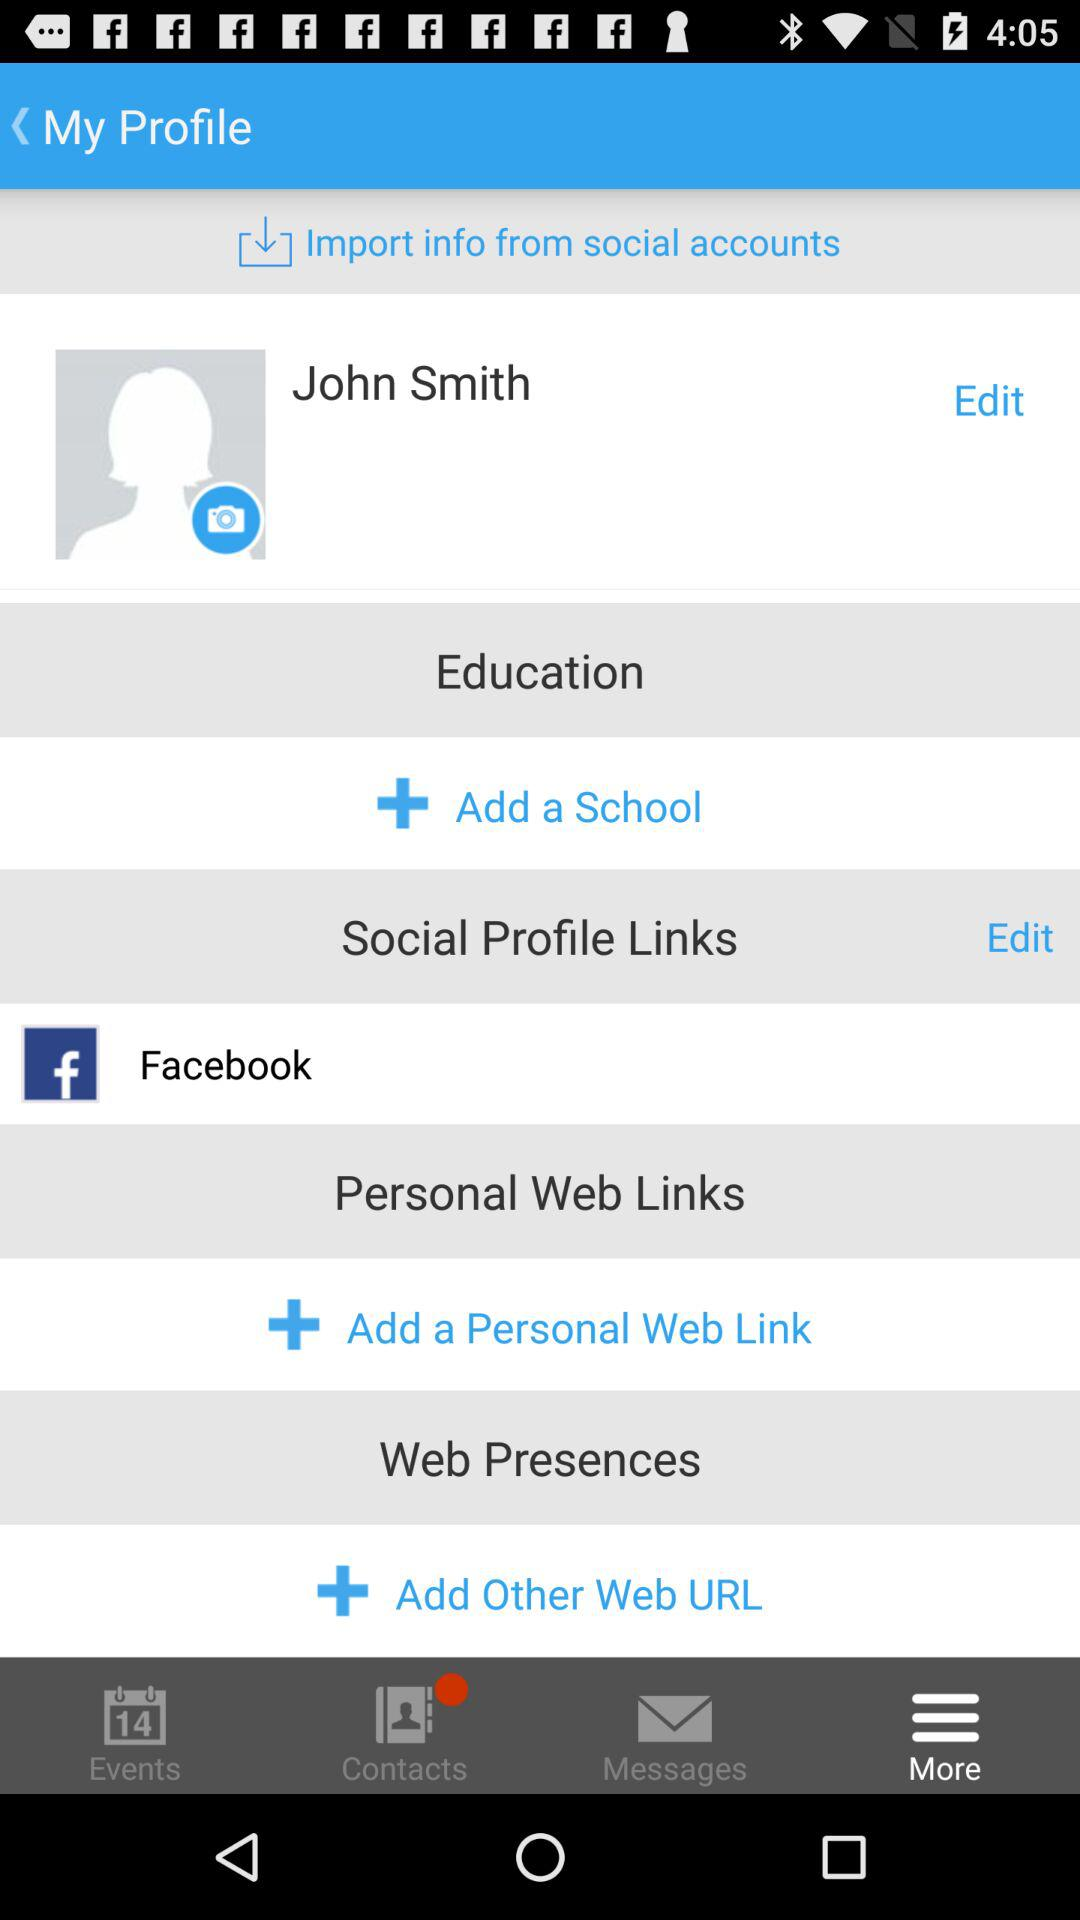What is the name of user? The name of the user is John Smith. 